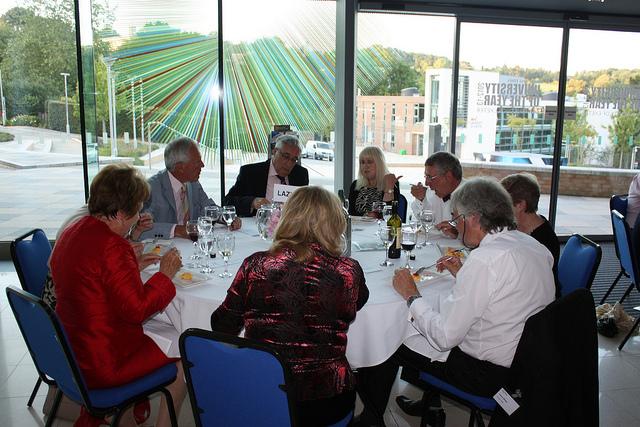Is the table round or square?
Write a very short answer. Round. Are they sitting in a bus?
Keep it brief. No. Why are there lines on the windows?
Write a very short answer. Reflection. How many glass panels are there?
Answer briefly. 6. 